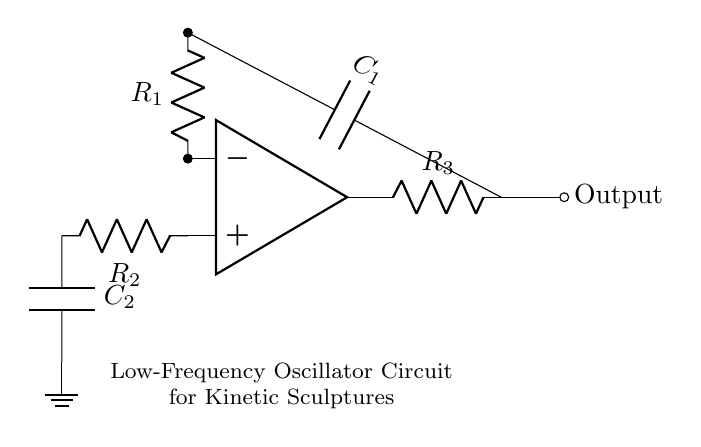What is the function of the op-amp in this circuit? The op-amp amplifies the input signal to produce an oscillating output. It compares the voltages at its inverting and non-inverting terminals to switch between high and low states, generating the oscillation necessary for controlling the sculpture.
Answer: Amplifier What is the role of capacitor C1? Capacitor C1, in conjunction with the resistors, helps determine the oscillation frequency of the circuit. It charges and discharges, creating a time delay that influences how fast the output oscillates.
Answer: Frequency timing How many resistors are present in the circuit? The circuit contains three resistors connected in various configurations with the op-amp and capacitors. Each resistor has a specific purpose for controlling gain or timing in the oscillator.
Answer: Three What component acts as the main output element? The output comes from the op-amp which sends the oscillating signal to the output node, indicating the periodic behavior of the circuit and its functioning as an oscillator for controlling movements in sculptures.
Answer: Op-amp output What determines the frequency of oscillation in this circuit? The frequency is determined by the values of resistors R1, R2, and capacitor C1, which establish the charge and discharge times needed for the oscillation, consistent with the design formula for the oscillator circuit.
Answer: Resistor and capacitor values Why is there a ground connection in this circuit? The ground connection provides a reference point for the voltages in the circuit, ensuring proper operation of the components by stabilizing the circuit's electrical reference level, which is essential for accurate oscillation.
Answer: Reference point 